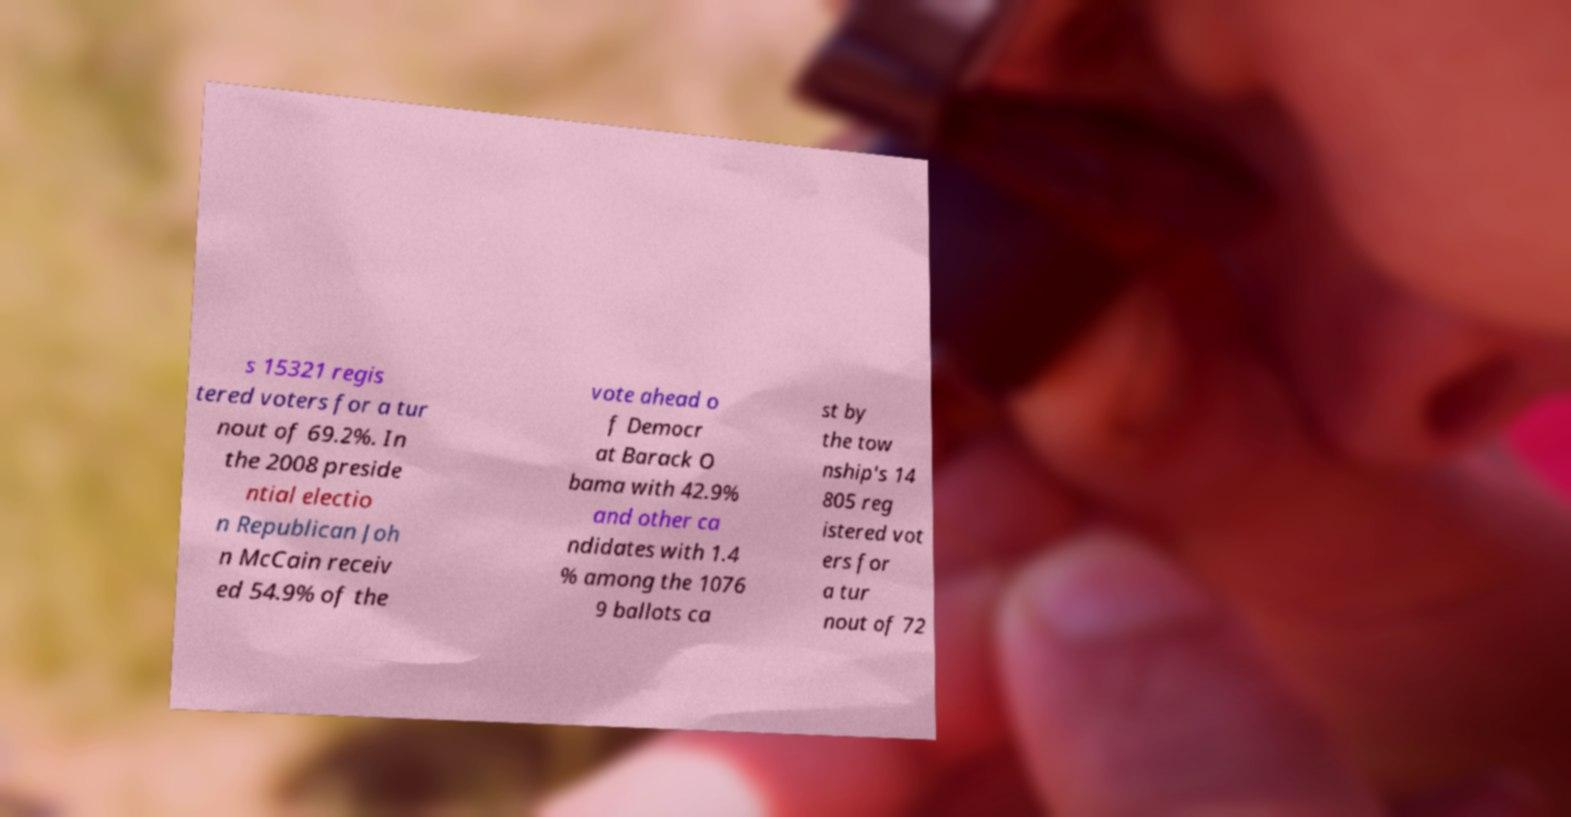Please identify and transcribe the text found in this image. s 15321 regis tered voters for a tur nout of 69.2%. In the 2008 preside ntial electio n Republican Joh n McCain receiv ed 54.9% of the vote ahead o f Democr at Barack O bama with 42.9% and other ca ndidates with 1.4 % among the 1076 9 ballots ca st by the tow nship's 14 805 reg istered vot ers for a tur nout of 72 